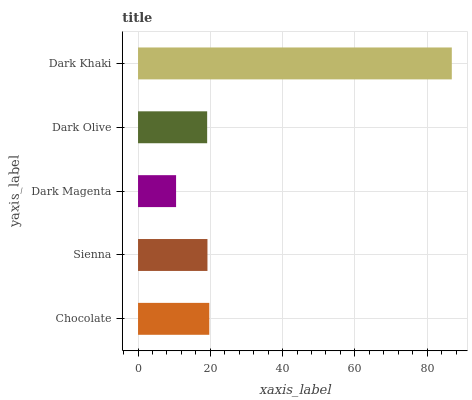Is Dark Magenta the minimum?
Answer yes or no. Yes. Is Dark Khaki the maximum?
Answer yes or no. Yes. Is Sienna the minimum?
Answer yes or no. No. Is Sienna the maximum?
Answer yes or no. No. Is Chocolate greater than Sienna?
Answer yes or no. Yes. Is Sienna less than Chocolate?
Answer yes or no. Yes. Is Sienna greater than Chocolate?
Answer yes or no. No. Is Chocolate less than Sienna?
Answer yes or no. No. Is Sienna the high median?
Answer yes or no. Yes. Is Sienna the low median?
Answer yes or no. Yes. Is Chocolate the high median?
Answer yes or no. No. Is Dark Olive the low median?
Answer yes or no. No. 